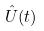Convert formula to latex. <formula><loc_0><loc_0><loc_500><loc_500>\hat { U } ( t )</formula> 